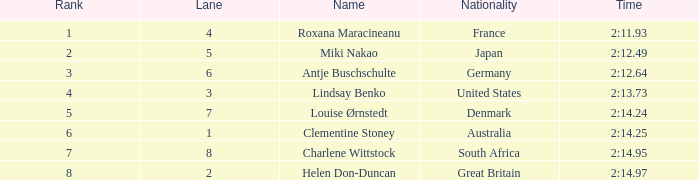What is the average Rank for a lane smaller than 3 with a nationality of Australia? 6.0. 